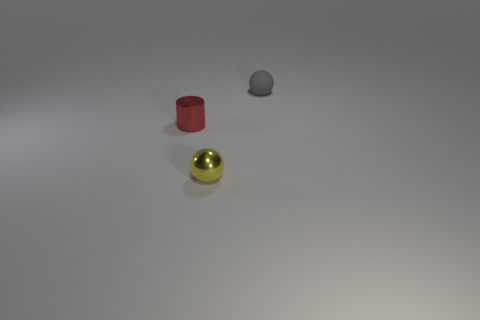Add 1 tiny gray things. How many objects exist? 4 Subtract all cylinders. How many objects are left? 2 Subtract 0 cyan balls. How many objects are left? 3 Subtract all blue spheres. Subtract all small yellow balls. How many objects are left? 2 Add 2 small yellow spheres. How many small yellow spheres are left? 3 Add 1 yellow balls. How many yellow balls exist? 2 